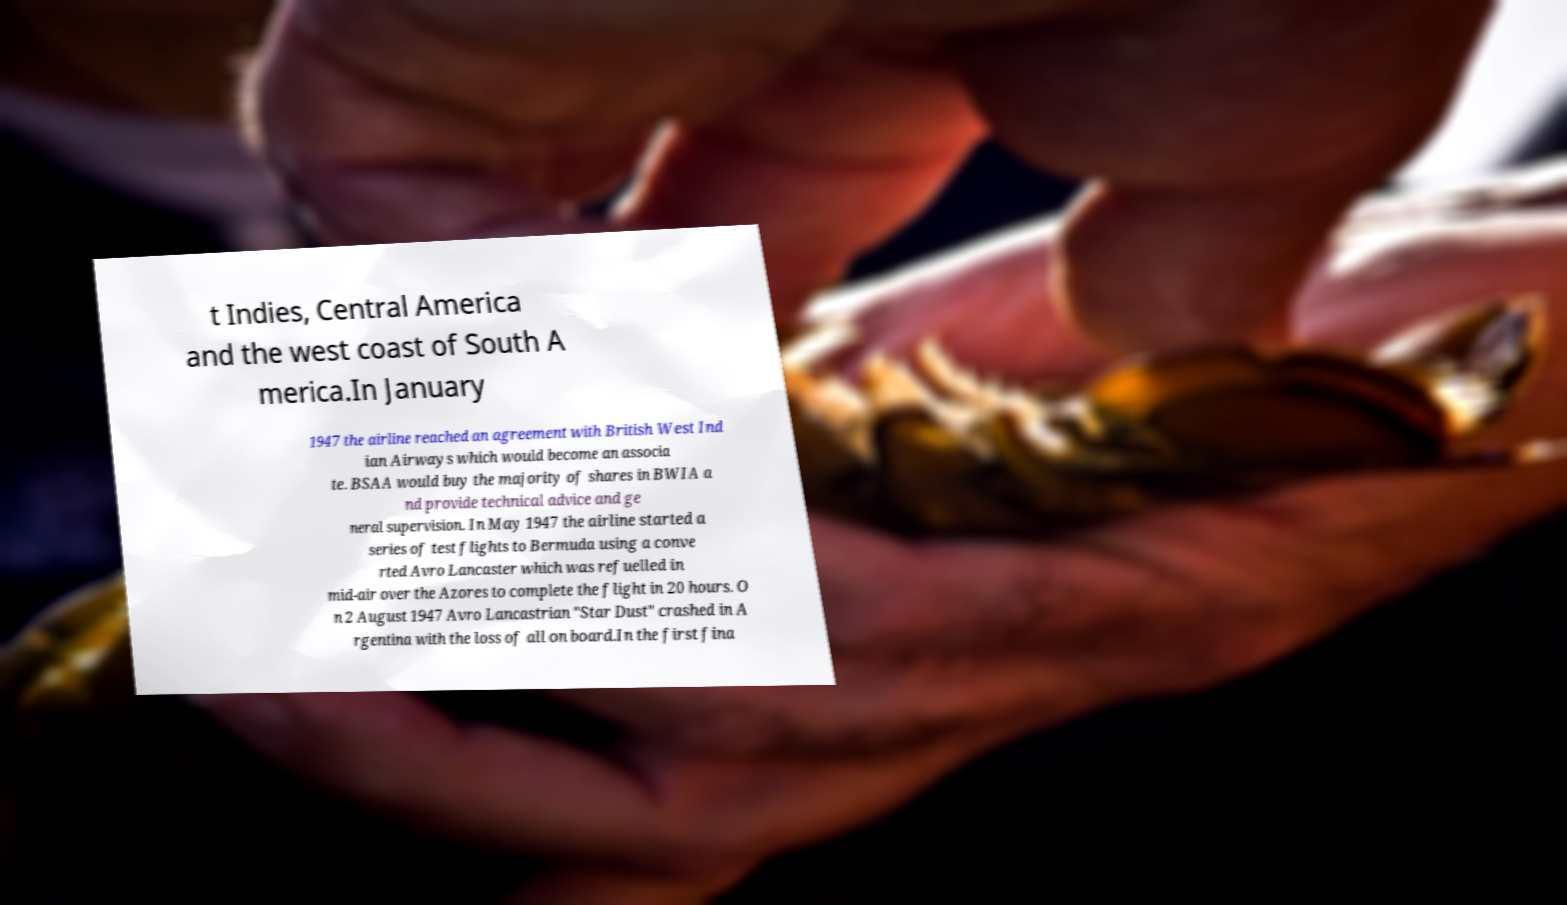For documentation purposes, I need the text within this image transcribed. Could you provide that? t Indies, Central America and the west coast of South A merica.In January 1947 the airline reached an agreement with British West Ind ian Airways which would become an associa te. BSAA would buy the majority of shares in BWIA a nd provide technical advice and ge neral supervision. In May 1947 the airline started a series of test flights to Bermuda using a conve rted Avro Lancaster which was refuelled in mid-air over the Azores to complete the flight in 20 hours. O n 2 August 1947 Avro Lancastrian "Star Dust" crashed in A rgentina with the loss of all on board.In the first fina 